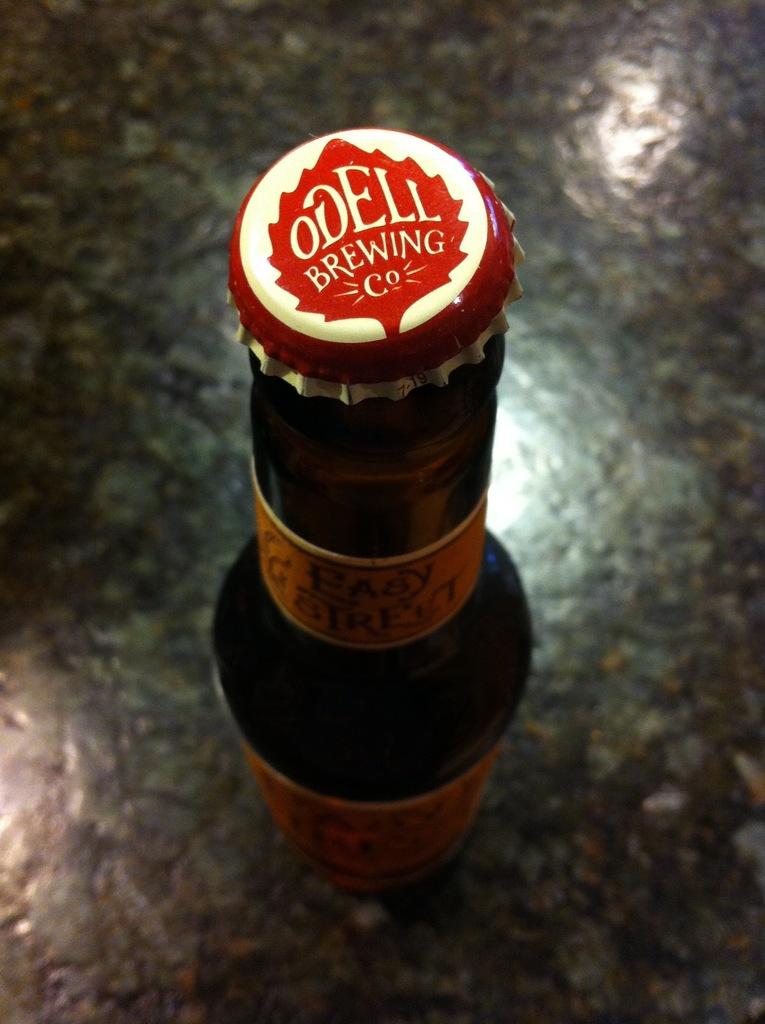What brewing company makes this beer?
Your answer should be compact. Odell. 